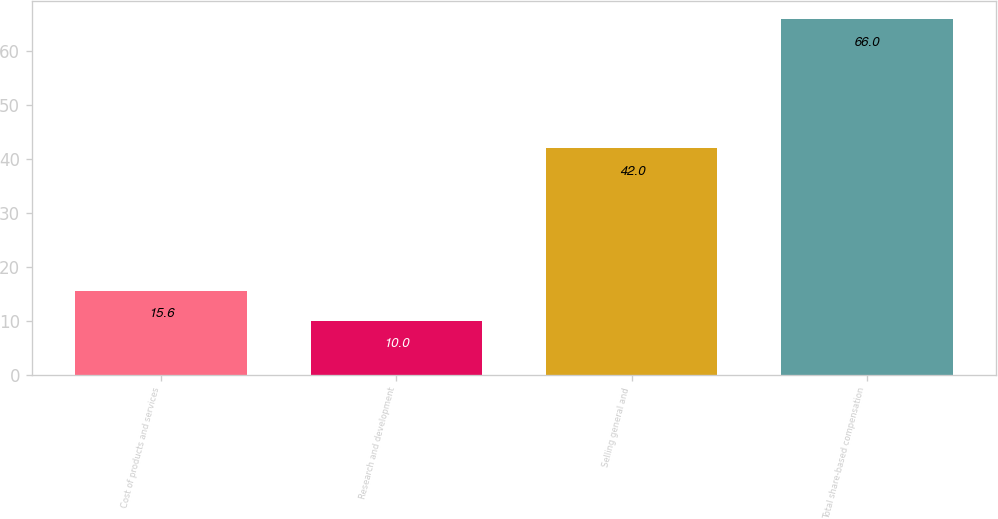Convert chart. <chart><loc_0><loc_0><loc_500><loc_500><bar_chart><fcel>Cost of products and services<fcel>Research and development<fcel>Selling general and<fcel>Total share-based compensation<nl><fcel>15.6<fcel>10<fcel>42<fcel>66<nl></chart> 